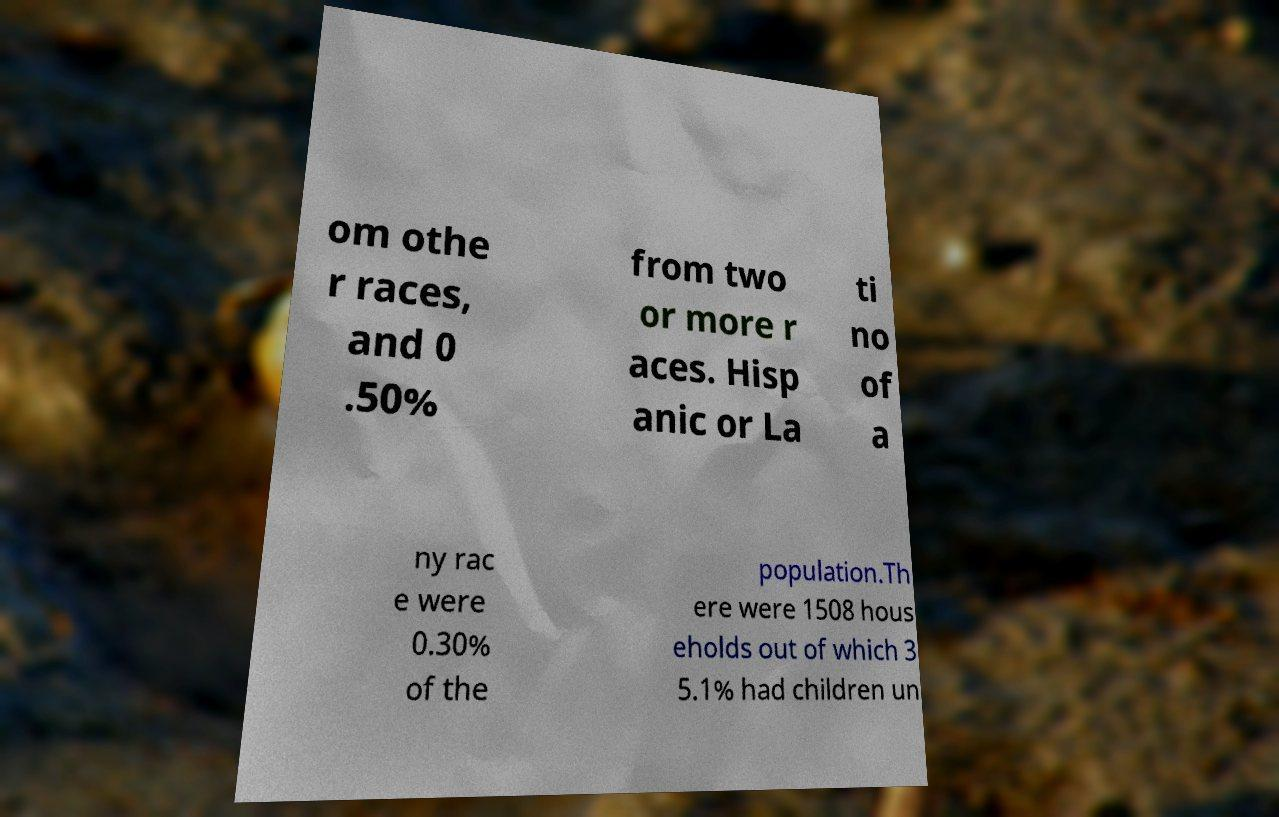I need the written content from this picture converted into text. Can you do that? om othe r races, and 0 .50% from two or more r aces. Hisp anic or La ti no of a ny rac e were 0.30% of the population.Th ere were 1508 hous eholds out of which 3 5.1% had children un 